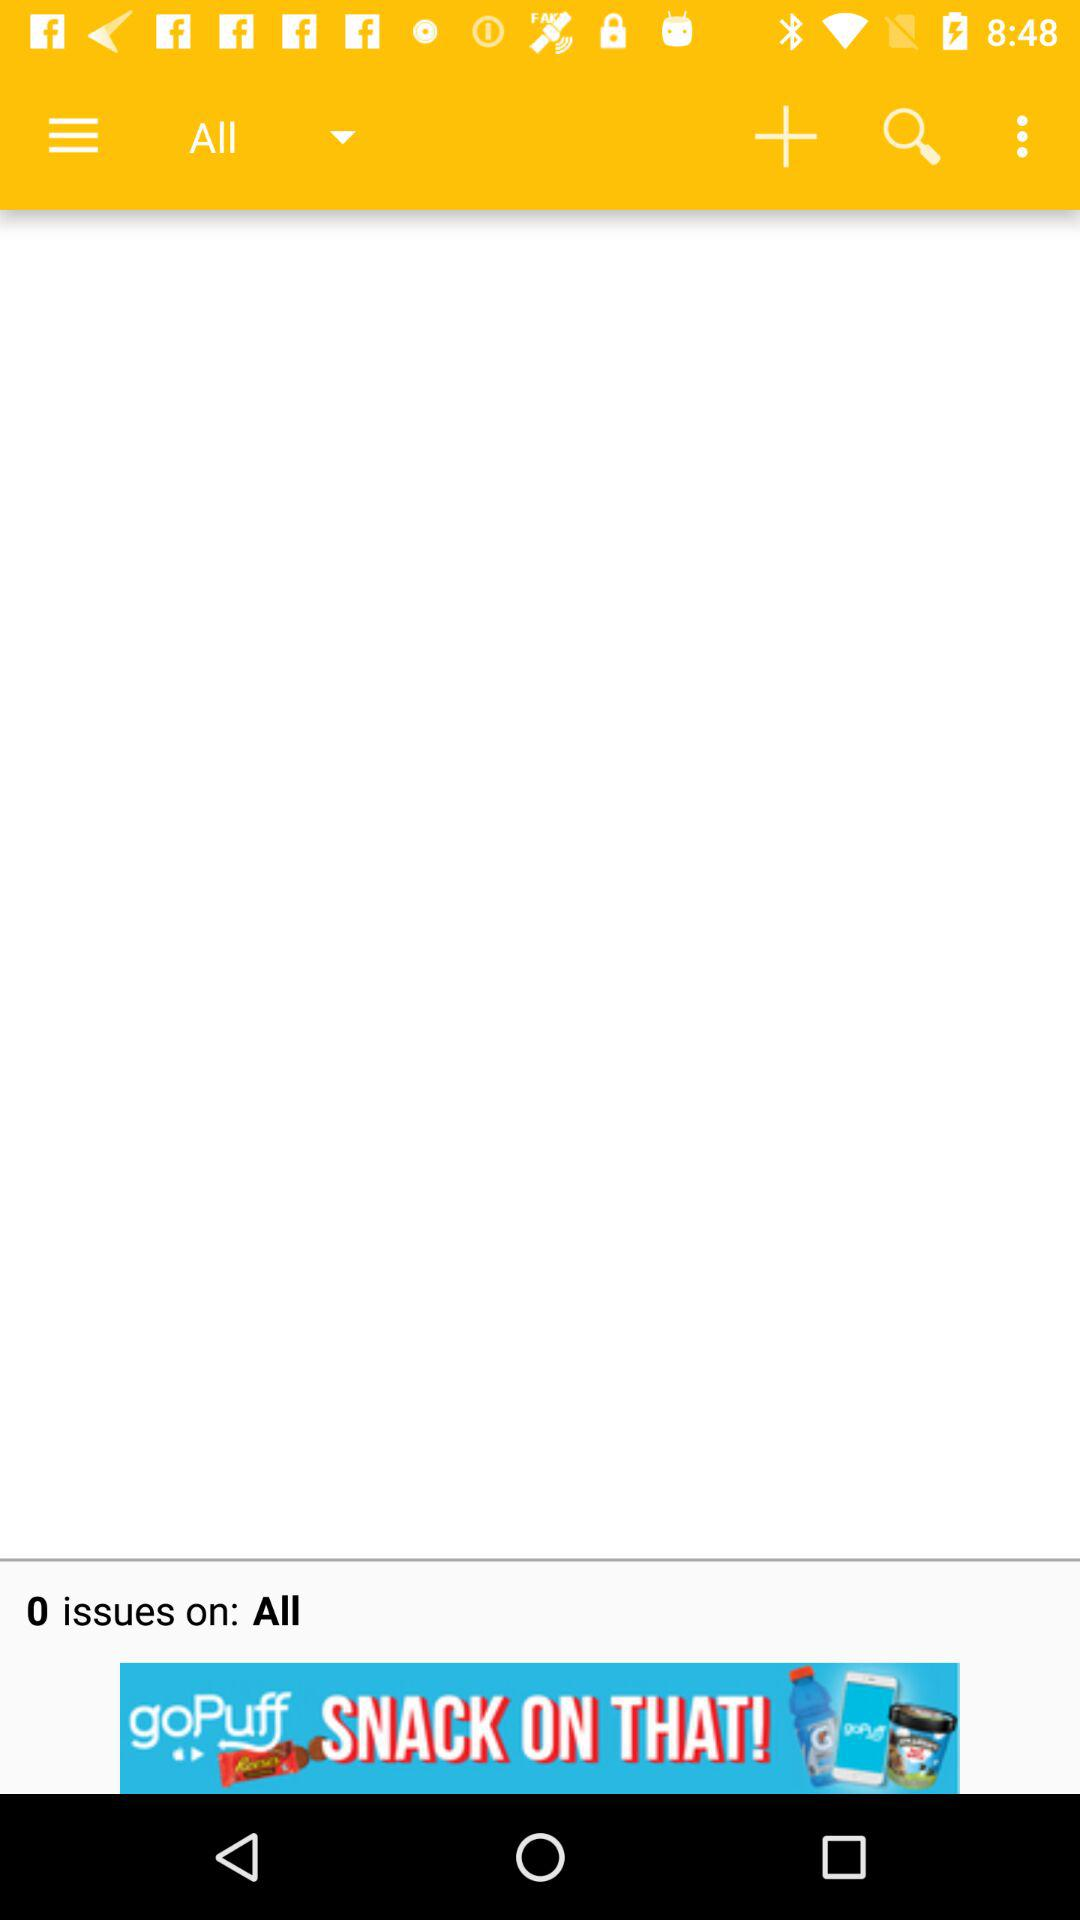What is the number of issues showing on the application? The number of issues is 0. 